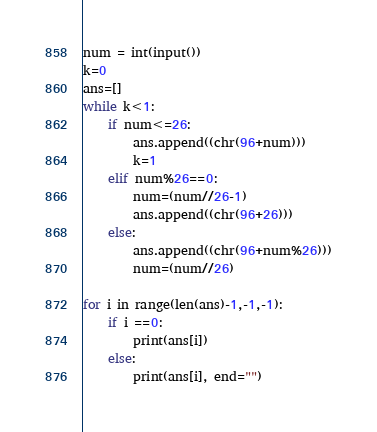Convert code to text. <code><loc_0><loc_0><loc_500><loc_500><_Python_>num = int(input())
k=0
ans=[]
while k<1:
    if num<=26:
        ans.append((chr(96+num)))
        k=1
    elif num%26==0:
        num=(num//26-1)
        ans.append((chr(96+26)))
    else:
        ans.append((chr(96+num%26)))
        num=(num//26)

for i in range(len(ans)-1,-1,-1):
    if i ==0:
        print(ans[i])
    else:
        print(ans[i], end="")</code> 